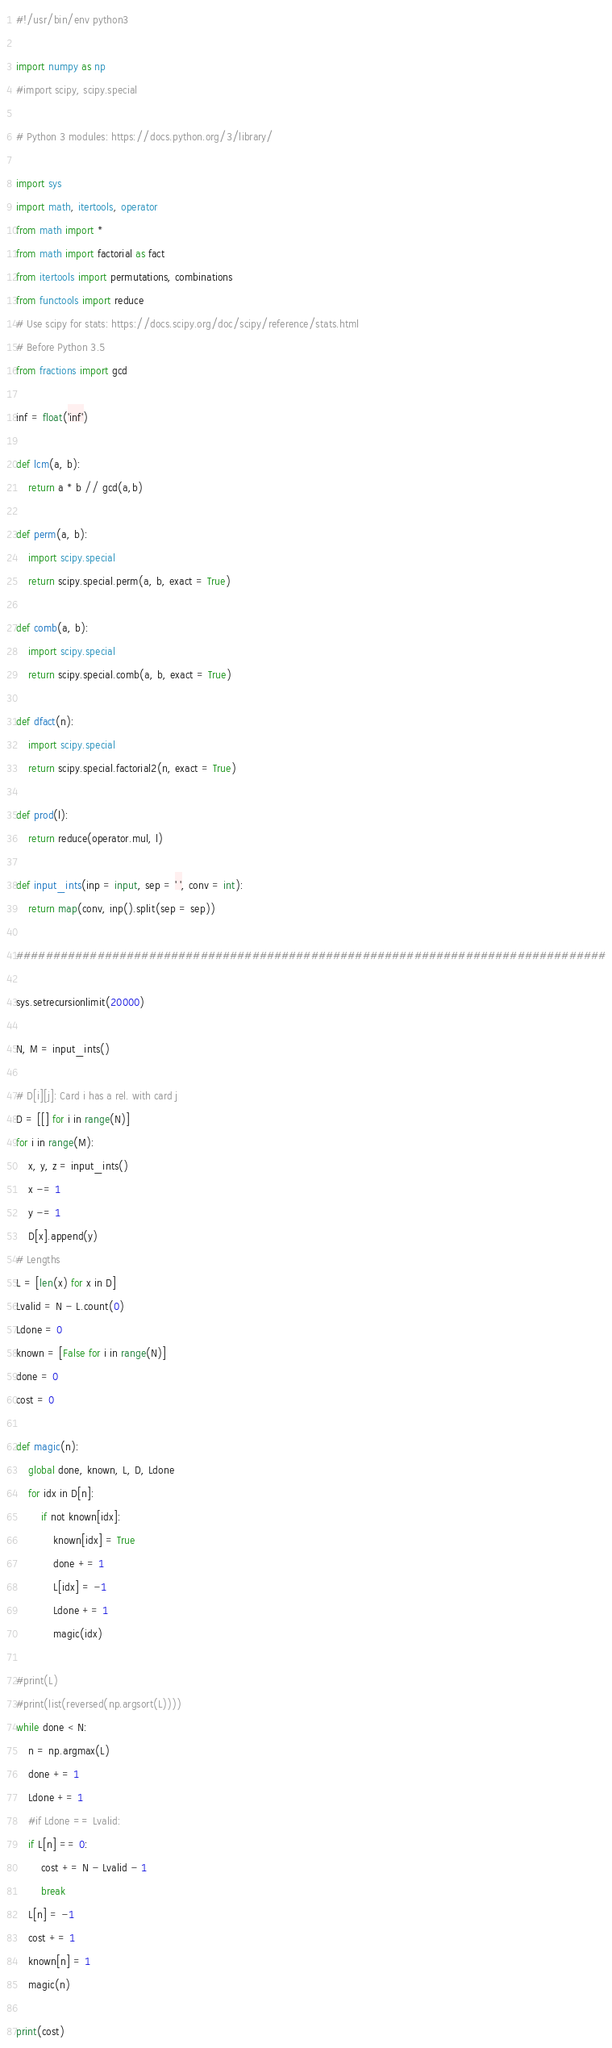Convert code to text. <code><loc_0><loc_0><loc_500><loc_500><_Python_>#!/usr/bin/env python3

import numpy as np
#import scipy, scipy.special

# Python 3 modules: https://docs.python.org/3/library/

import sys
import math, itertools, operator
from math import *
from math import factorial as fact
from itertools import permutations, combinations
from functools import reduce
# Use scipy for stats: https://docs.scipy.org/doc/scipy/reference/stats.html
# Before Python 3.5
from fractions import gcd

inf = float('inf')

def lcm(a, b):
    return a * b // gcd(a,b)

def perm(a, b):
    import scipy.special
    return scipy.special.perm(a, b, exact = True)

def comb(a, b):
    import scipy.special
    return scipy.special.comb(a, b, exact = True)

def dfact(n):
    import scipy.special
    return scipy.special.factorial2(n, exact = True)

def prod(l):
    return reduce(operator.mul, l)

def input_ints(inp = input, sep = ' ', conv = int):
    return map(conv, inp().split(sep = sep))

################################################################################

sys.setrecursionlimit(20000)

N, M = input_ints()

# D[i][j]: Card i has a rel. with card j
D = [[] for i in range(N)]
for i in range(M):
    x, y, z = input_ints()
    x -= 1
    y -= 1
    D[x].append(y)
# Lengths
L = [len(x) for x in D]
Lvalid = N - L.count(0)
Ldone = 0
known = [False for i in range(N)]
done = 0
cost = 0

def magic(n):
    global done, known, L, D, Ldone
    for idx in D[n]:
        if not known[idx]:
            known[idx] = True
            done += 1
            L[idx] = -1
            Ldone += 1
            magic(idx)

#print(L)
#print(list(reversed(np.argsort(L))))
while done < N:
    n = np.argmax(L)
    done += 1
    Ldone += 1
    #if Ldone == Lvalid:
    if L[n] == 0:
        cost += N - Lvalid - 1
        break
    L[n] = -1
    cost += 1
    known[n] = 1
    magic(n)

print(cost)
</code> 